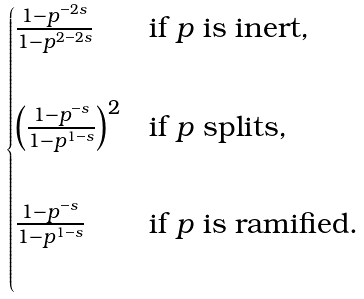<formula> <loc_0><loc_0><loc_500><loc_500>\begin{cases} \frac { 1 - p ^ { - 2 s } } { 1 - p ^ { 2 - 2 s } } & \text {if $p$ is inert} , \\ \\ \left ( \frac { 1 - p ^ { - s } } { 1 - p ^ { 1 - s } } \right ) ^ { 2 } & \text {if $p$ splits} , \\ \\ \frac { 1 - p ^ { - s } } { 1 - p ^ { 1 - s } } & \text {if $p$ is ramified} . \\ \\ \end{cases}</formula> 